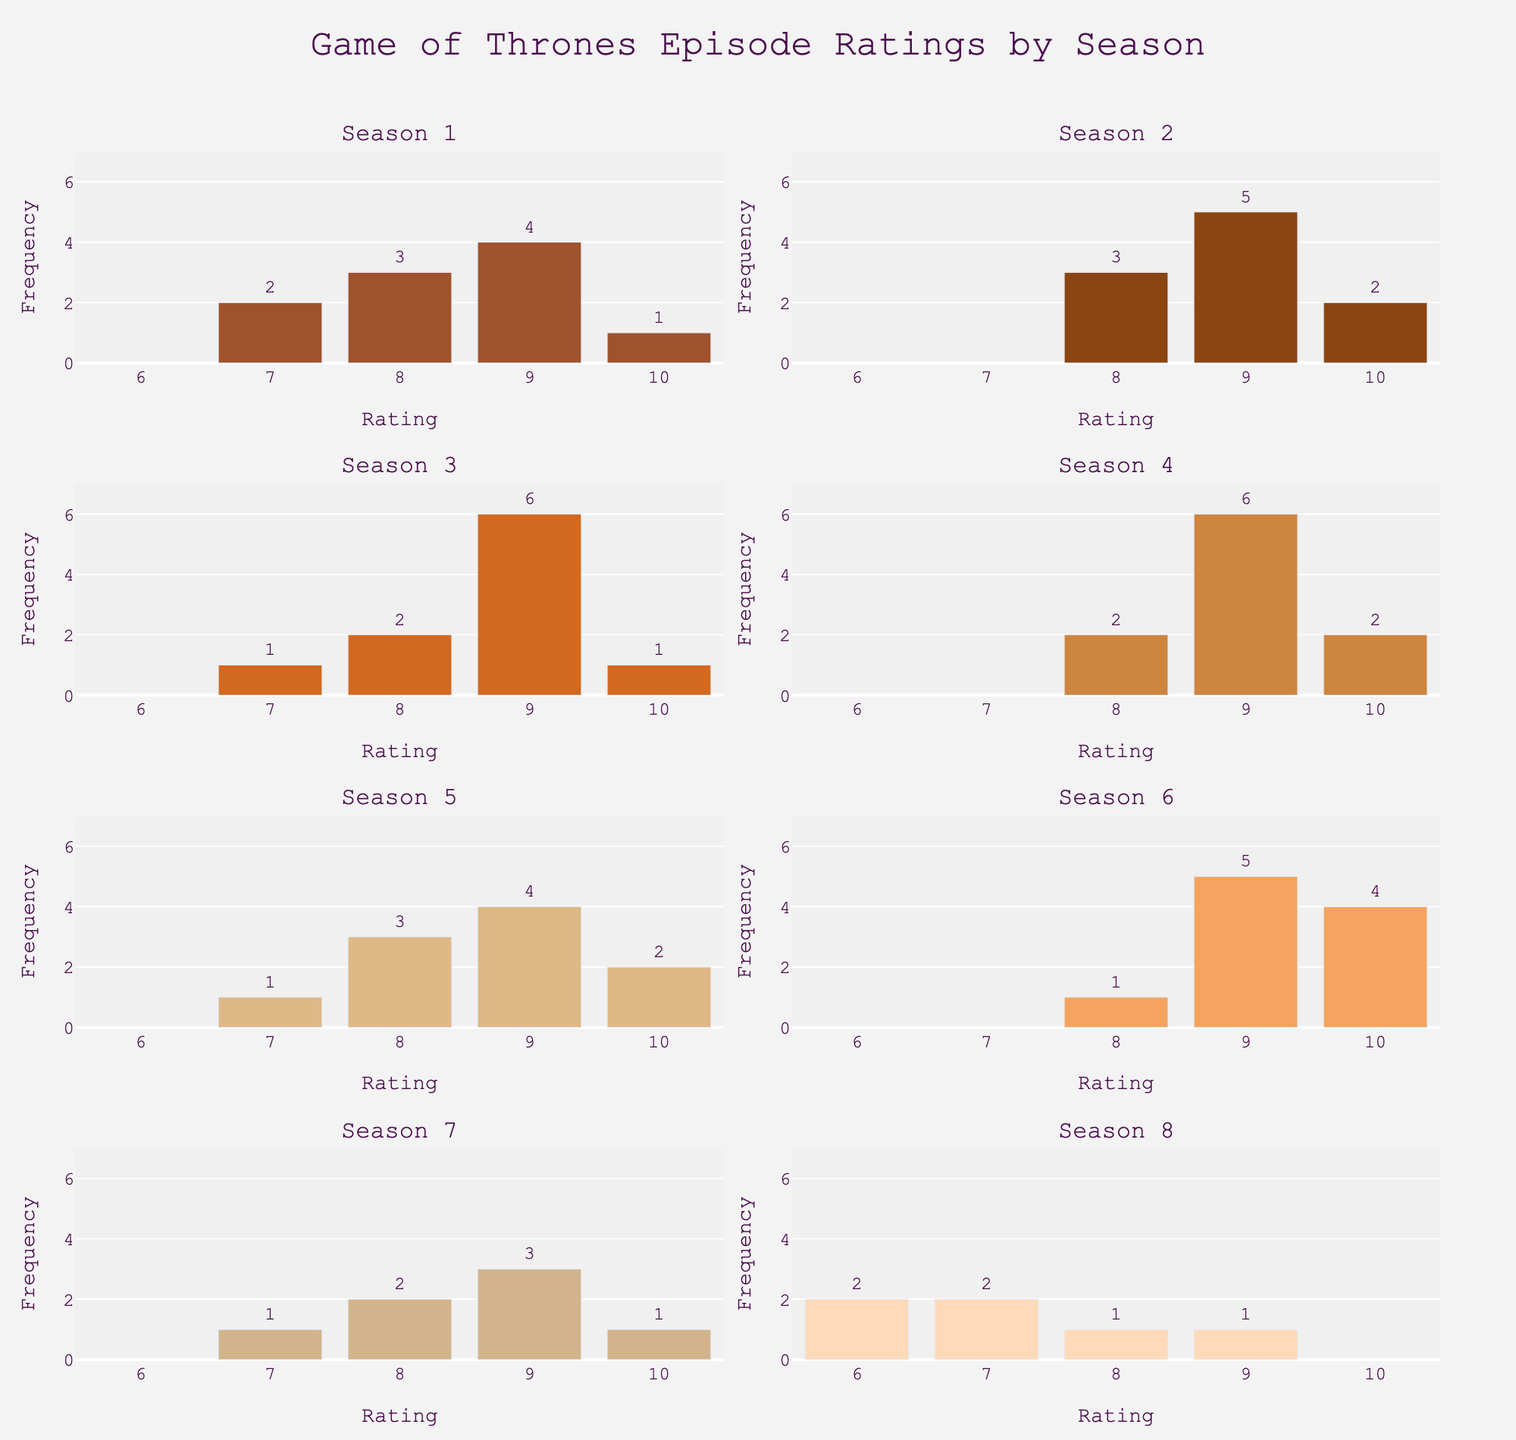what is the highest-rated episode in season 1? The highest rating shown in the histogram for season 1 is 10. This can be seen on the x-axis value with the corresponding bar indicating a frequency of 1.
Answer: 10 which season has the most frequent ratings among 9 and 10? By comparing the heights of the bars for ratings 9 and 10, we see that season 4 has a total frequency of 8 for ratings 9 and 10 combined (6 for rating 9 and 2 for rating 10). This is the highest among all seasons.
Answer: Season 4 what is the average frequency of episode ratings in season 2? To find the average, add the frequencies of all ratings in season 2 and divide by the number of ratings. The total frequency is 3 + 5 + 2 = 10, and there are 3 different ratings, so the average is 10 / 3 ≈ 3.33.
Answer: 3.33 which season has the least number of ratings with a frequency of 1? To find this, count the bars with a height of 1 in each subplot. Season 8 has only one bar with a frequency of 1.
Answer: Season 8 does season 7 have any ratings lower than 7? The histogram for season 7 does not have any bars extending below the rating of 7, which confirms that there are no ratings lower than 7 for this season.
Answer: No which season has the most varied episode ratings? We can evaluate variability by looking at the spread and the number of distinct rating bins with non-zero frequencies. Season 8 has ratings ranging from 6 to 9, showing a wider range of ratings compared to other seasons.
Answer: Season 8 what is the mode-rating of season 6? The mode is the most frequently occurring rating. For season 6, the rating with the highest frequency is 9, with a frequency of 5.
Answer: 9 how many episodes have a rating of 9 in season 3? In the subplot for season 3, the bar for the rating of 9 shows a height (frequency) of 6. Thus, there are 6 episodes with a rating of 9 in season 3.
Answer: 6 which season has the highest total frequency of ratings? To find this, sum the frequencies of all ratings for each season and compare. Season 3 has the highest total frequency (1+2+6+1=10).
Answer: Season 3 